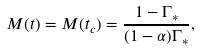Convert formula to latex. <formula><loc_0><loc_0><loc_500><loc_500>M ( t ) = M ( t _ { c } ) = \frac { 1 - \Gamma _ { \ast } } { ( 1 - \alpha ) \Gamma _ { \ast } } ,</formula> 